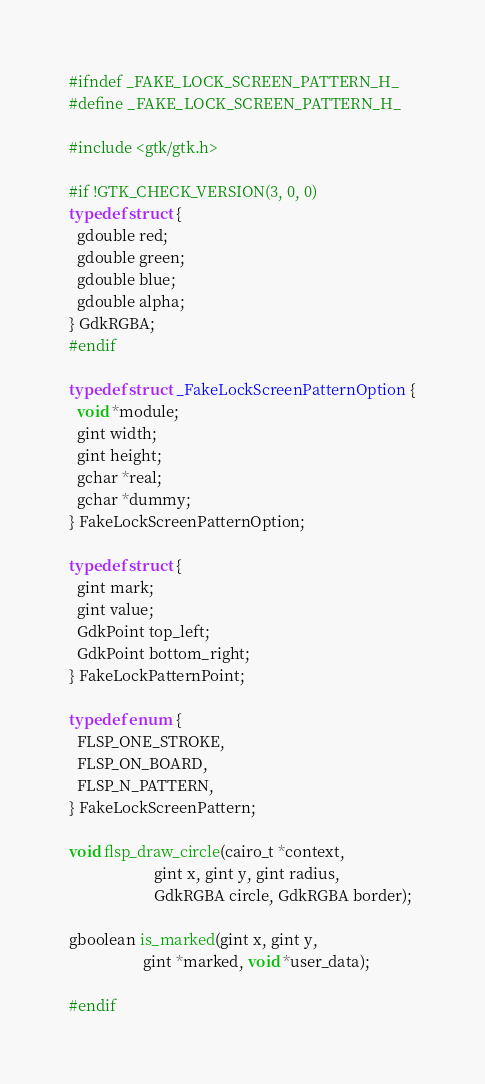<code> <loc_0><loc_0><loc_500><loc_500><_C_>#ifndef _FAKE_LOCK_SCREEN_PATTERN_H_
#define _FAKE_LOCK_SCREEN_PATTERN_H_

#include <gtk/gtk.h>

#if !GTK_CHECK_VERSION(3, 0, 0)
typedef struct {
  gdouble red;
  gdouble green;
  gdouble blue;
  gdouble alpha;
} GdkRGBA;
#endif

typedef struct _FakeLockScreenPatternOption {
  void *module;
  gint width;
  gint height;
  gchar *real;
  gchar *dummy;
} FakeLockScreenPatternOption;

typedef struct {
  gint mark;
  gint value;
  GdkPoint top_left;
  GdkPoint bottom_right;
} FakeLockPatternPoint;

typedef enum {
  FLSP_ONE_STROKE,
  FLSP_ON_BOARD,
  FLSP_N_PATTERN,
} FakeLockScreenPattern;

void flsp_draw_circle(cairo_t *context,
                      gint x, gint y, gint radius,
                      GdkRGBA circle, GdkRGBA border);

gboolean is_marked(gint x, gint y,
                   gint *marked, void *user_data);

#endif
</code> 